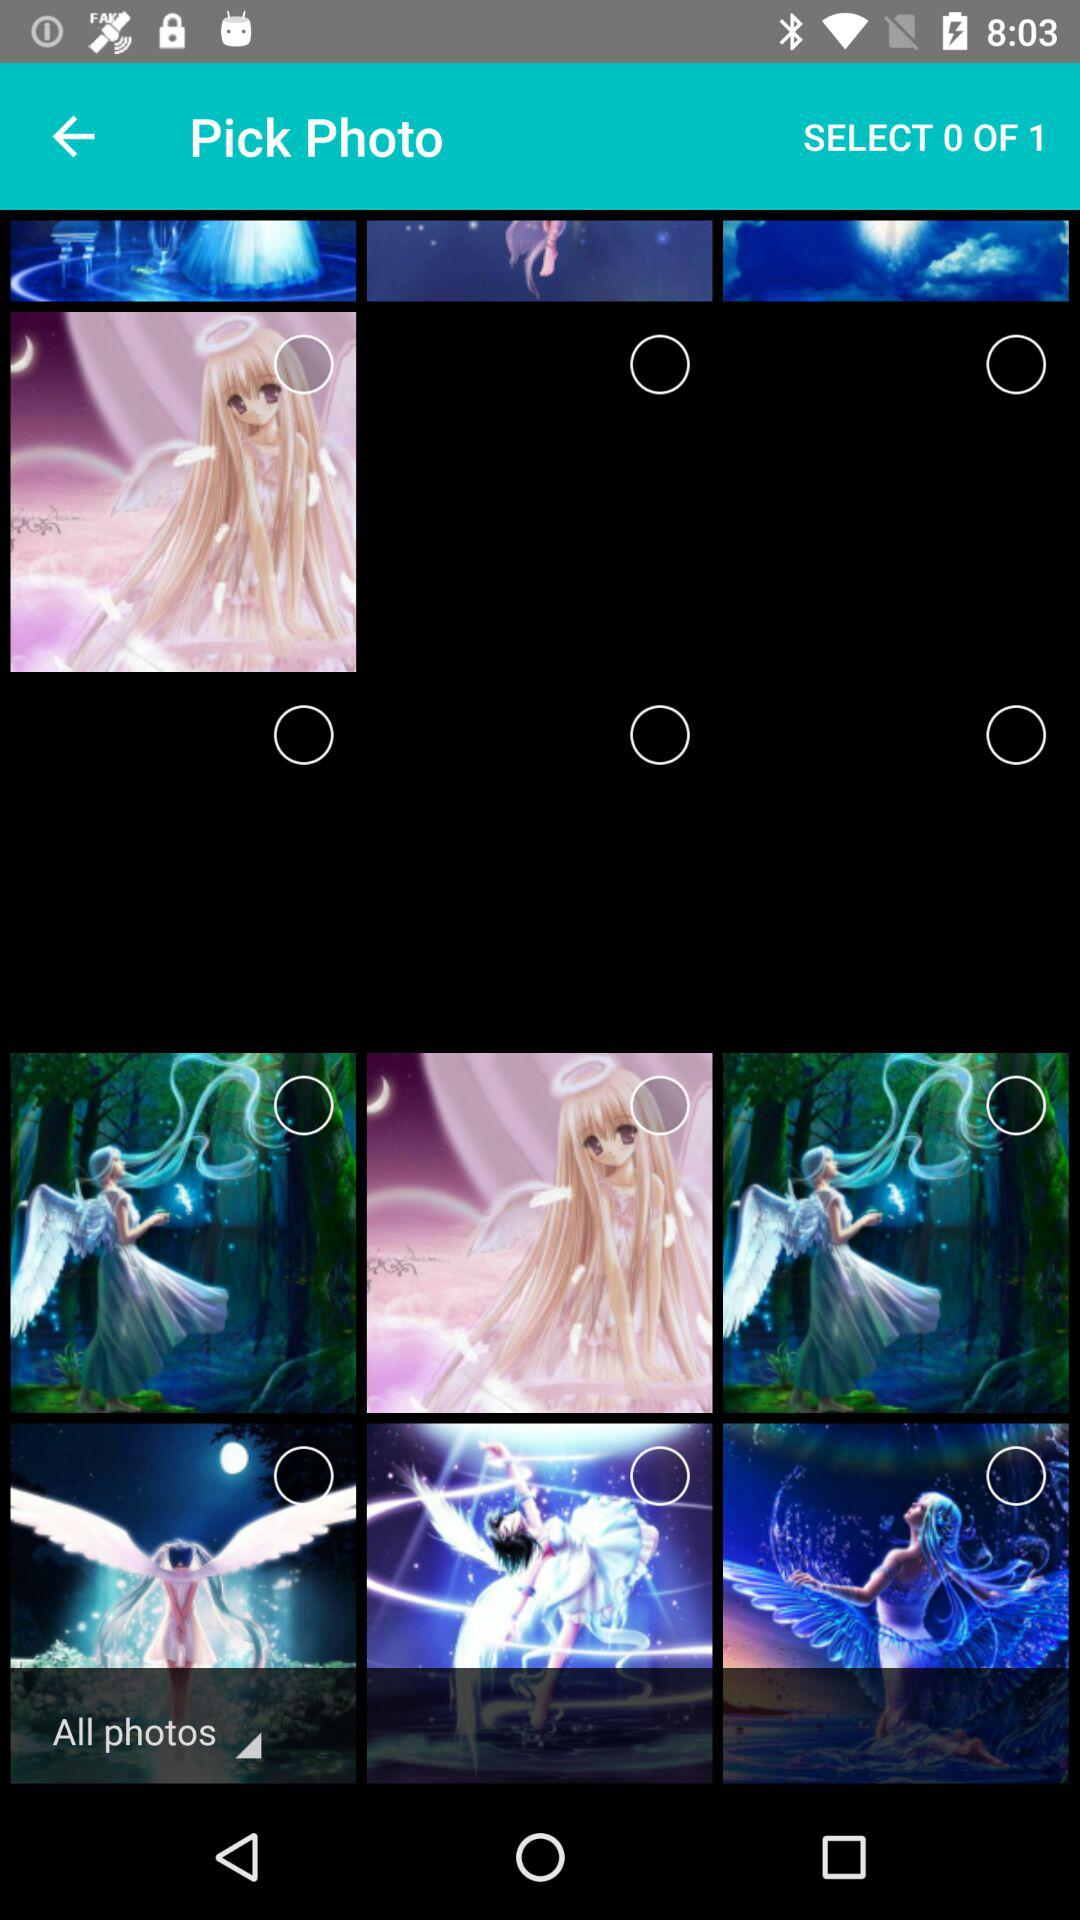How many selected photos are there? There are 0 selected photos. 